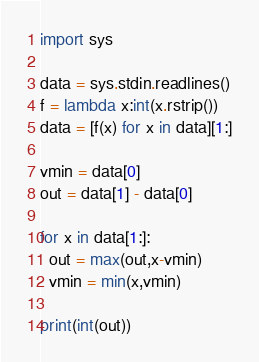<code> <loc_0><loc_0><loc_500><loc_500><_Python_>import sys

data = sys.stdin.readlines()
f = lambda x:int(x.rstrip())
data = [f(x) for x in data][1:]

vmin = data[0]
out = data[1] - data[0]

for x in data[1:]:
  out = max(out,x-vmin)
  vmin = min(x,vmin)

print(int(out))

</code> 